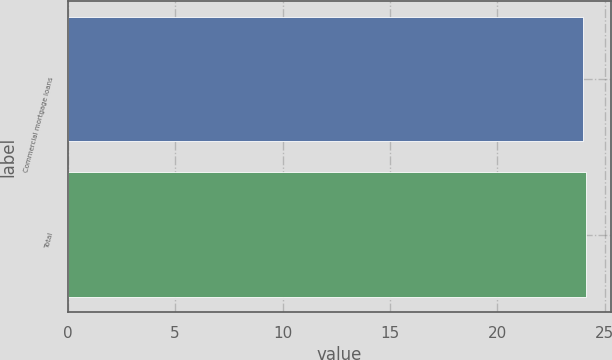Convert chart. <chart><loc_0><loc_0><loc_500><loc_500><bar_chart><fcel>Commercial mortgage loans<fcel>Total<nl><fcel>24<fcel>24.1<nl></chart> 